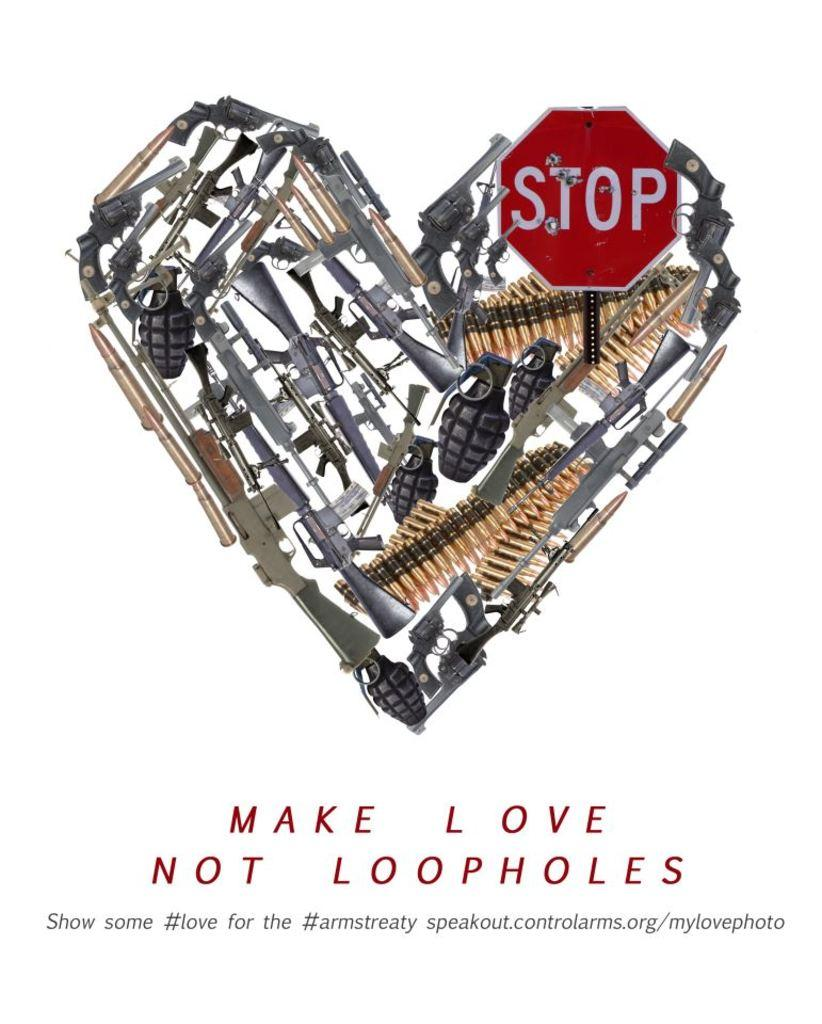Provide a one-sentence caption for the provided image. book with a heart on the cover called make love not loopholes. 